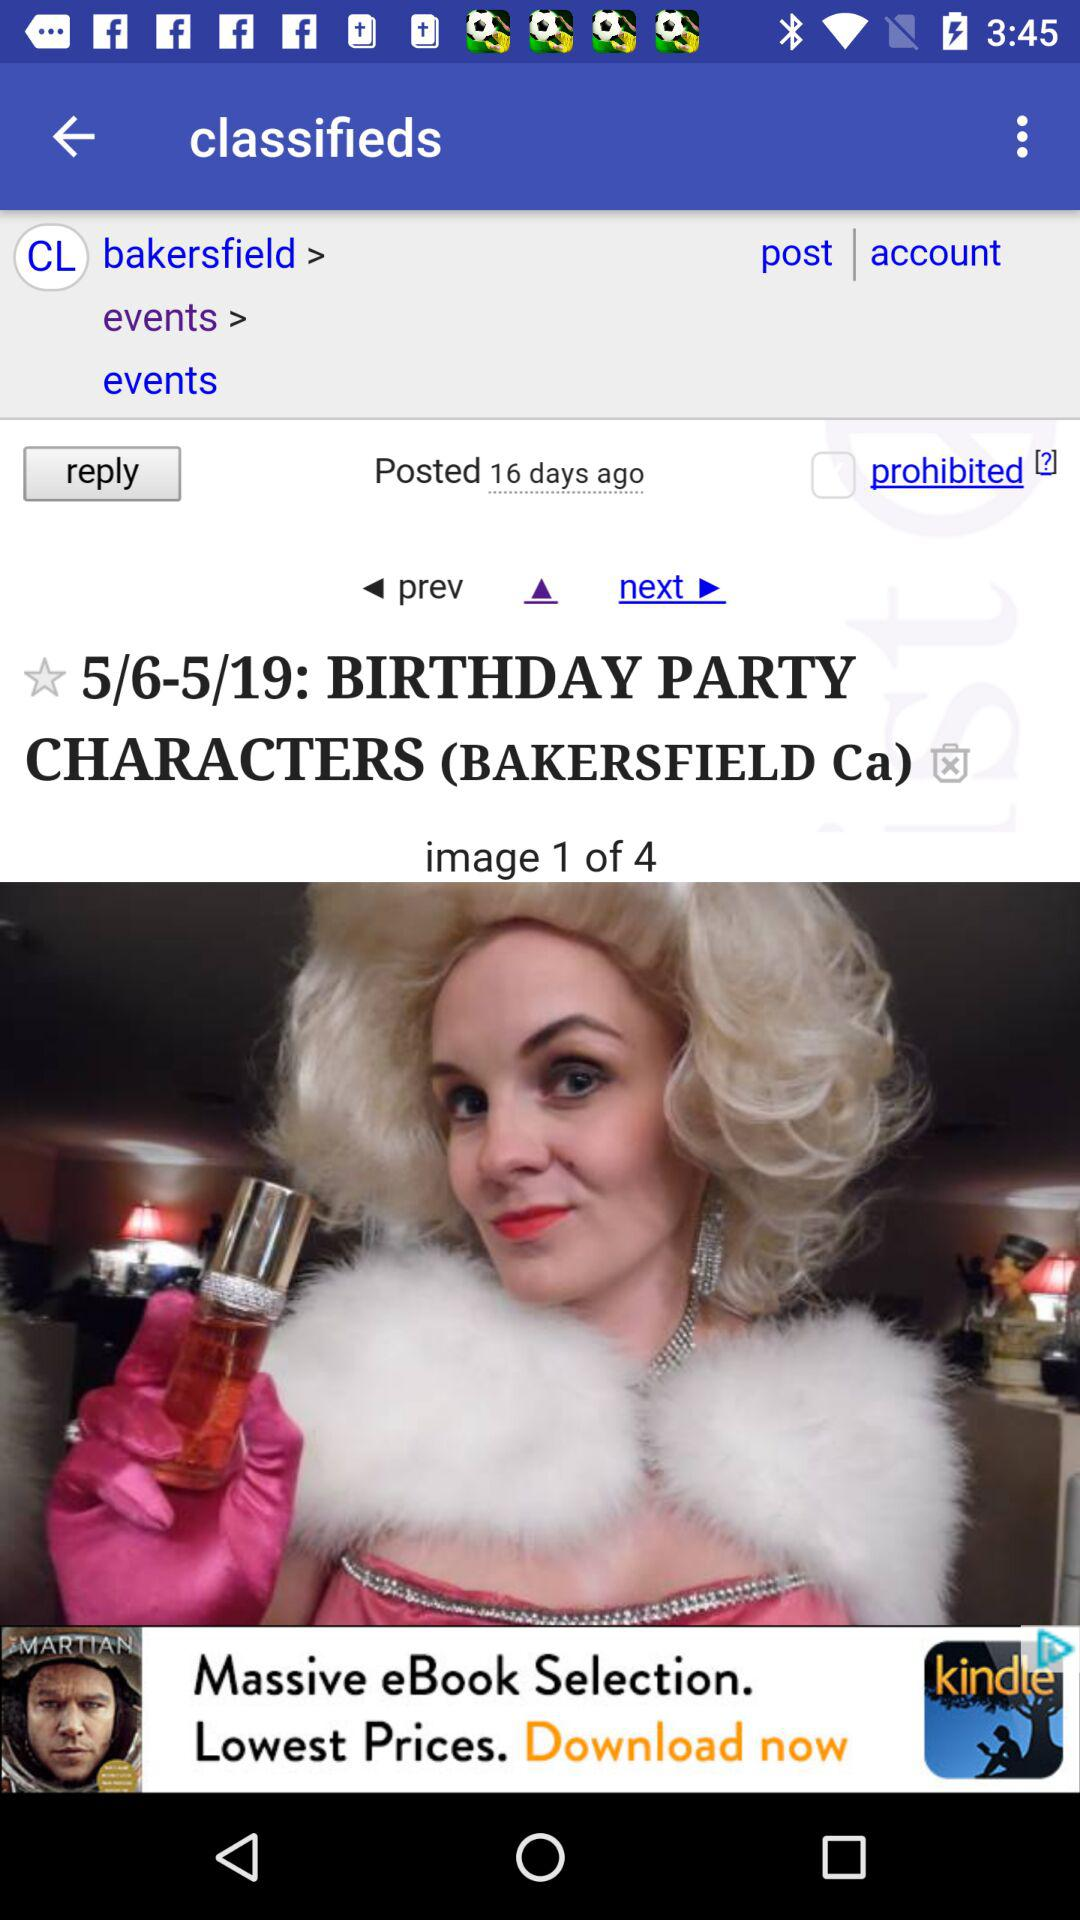How many total images are there? There are 4 images in total. 